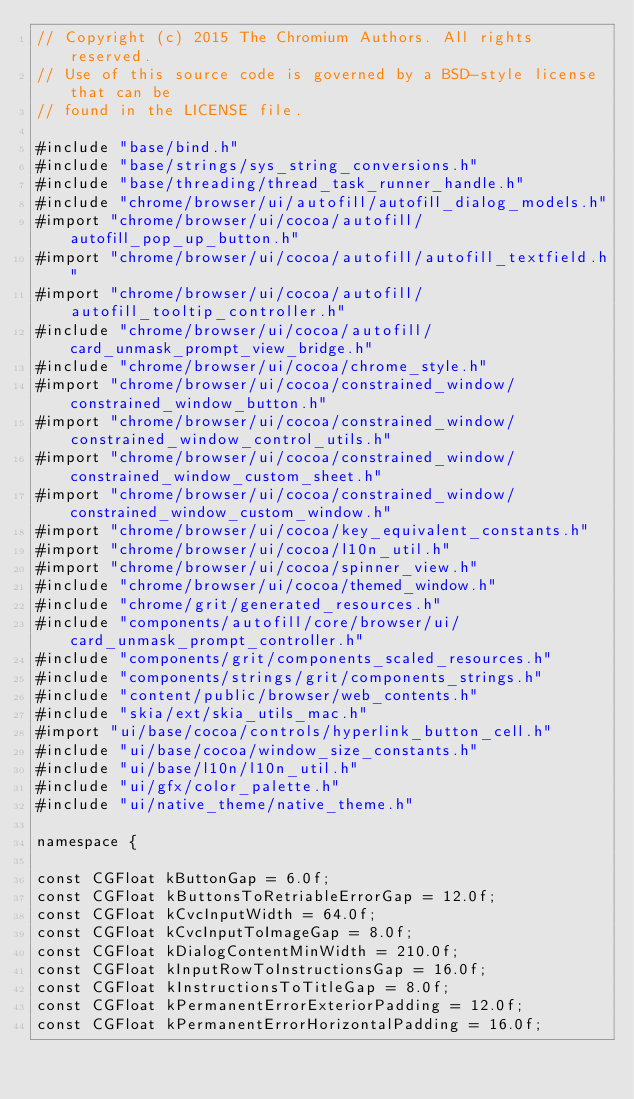Convert code to text. <code><loc_0><loc_0><loc_500><loc_500><_ObjectiveC_>// Copyright (c) 2015 The Chromium Authors. All rights reserved.
// Use of this source code is governed by a BSD-style license that can be
// found in the LICENSE file.

#include "base/bind.h"
#include "base/strings/sys_string_conversions.h"
#include "base/threading/thread_task_runner_handle.h"
#include "chrome/browser/ui/autofill/autofill_dialog_models.h"
#import "chrome/browser/ui/cocoa/autofill/autofill_pop_up_button.h"
#import "chrome/browser/ui/cocoa/autofill/autofill_textfield.h"
#import "chrome/browser/ui/cocoa/autofill/autofill_tooltip_controller.h"
#include "chrome/browser/ui/cocoa/autofill/card_unmask_prompt_view_bridge.h"
#include "chrome/browser/ui/cocoa/chrome_style.h"
#import "chrome/browser/ui/cocoa/constrained_window/constrained_window_button.h"
#import "chrome/browser/ui/cocoa/constrained_window/constrained_window_control_utils.h"
#import "chrome/browser/ui/cocoa/constrained_window/constrained_window_custom_sheet.h"
#import "chrome/browser/ui/cocoa/constrained_window/constrained_window_custom_window.h"
#import "chrome/browser/ui/cocoa/key_equivalent_constants.h"
#import "chrome/browser/ui/cocoa/l10n_util.h"
#import "chrome/browser/ui/cocoa/spinner_view.h"
#include "chrome/browser/ui/cocoa/themed_window.h"
#include "chrome/grit/generated_resources.h"
#include "components/autofill/core/browser/ui/card_unmask_prompt_controller.h"
#include "components/grit/components_scaled_resources.h"
#include "components/strings/grit/components_strings.h"
#include "content/public/browser/web_contents.h"
#include "skia/ext/skia_utils_mac.h"
#import "ui/base/cocoa/controls/hyperlink_button_cell.h"
#include "ui/base/cocoa/window_size_constants.h"
#include "ui/base/l10n/l10n_util.h"
#include "ui/gfx/color_palette.h"
#include "ui/native_theme/native_theme.h"

namespace {

const CGFloat kButtonGap = 6.0f;
const CGFloat kButtonsToRetriableErrorGap = 12.0f;
const CGFloat kCvcInputWidth = 64.0f;
const CGFloat kCvcInputToImageGap = 8.0f;
const CGFloat kDialogContentMinWidth = 210.0f;
const CGFloat kInputRowToInstructionsGap = 16.0f;
const CGFloat kInstructionsToTitleGap = 8.0f;
const CGFloat kPermanentErrorExteriorPadding = 12.0f;
const CGFloat kPermanentErrorHorizontalPadding = 16.0f;</code> 